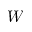<formula> <loc_0><loc_0><loc_500><loc_500>W</formula> 